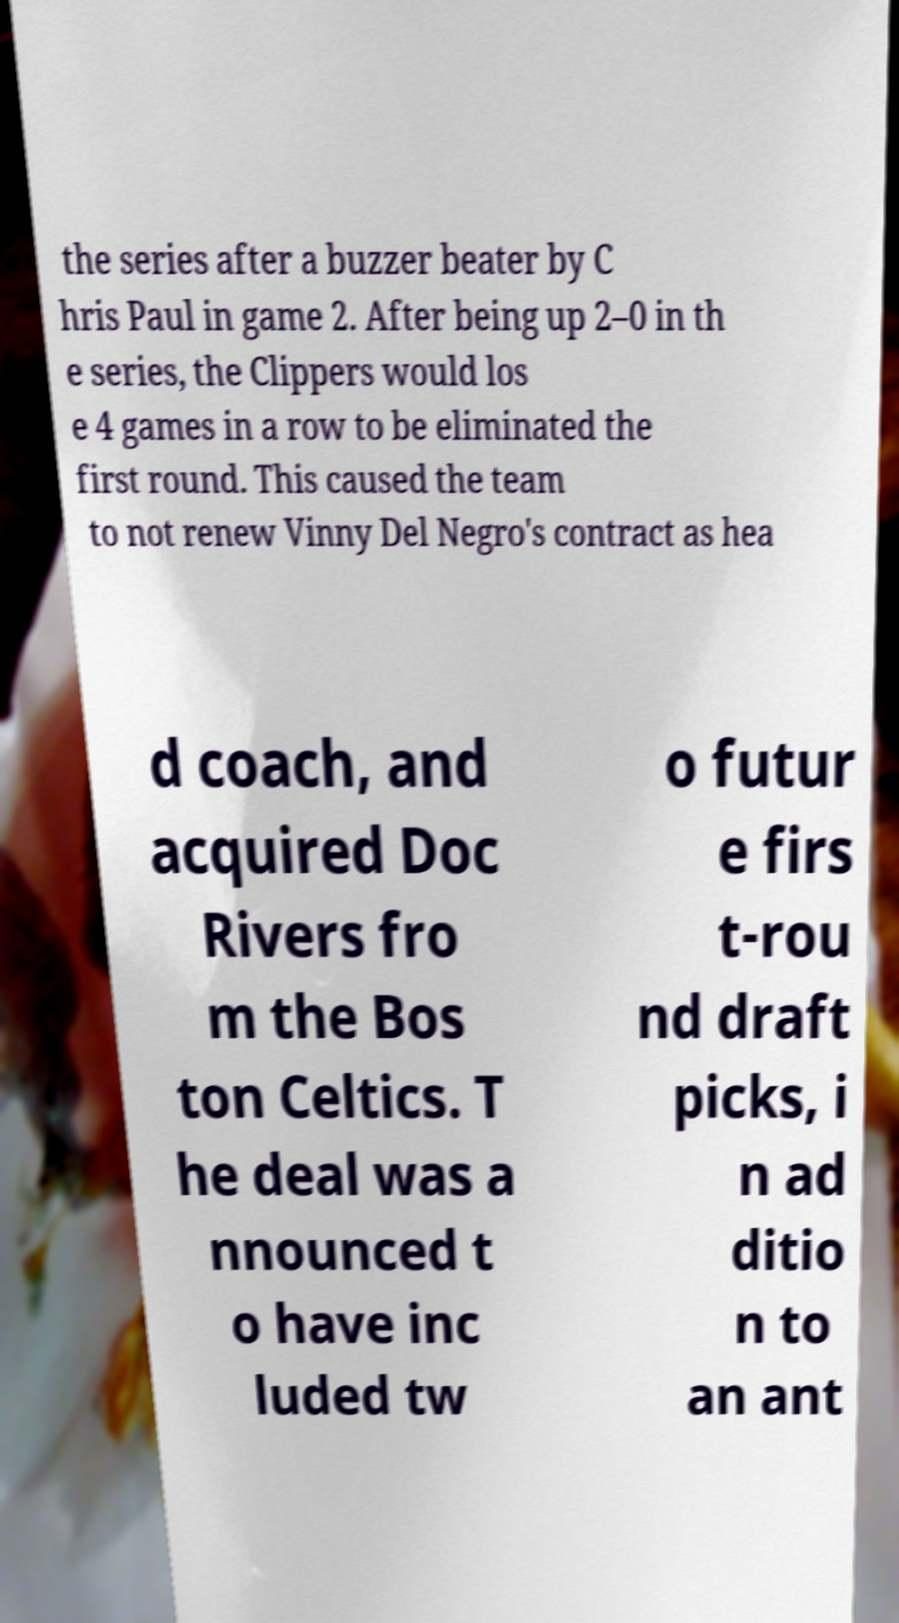I need the written content from this picture converted into text. Can you do that? the series after a buzzer beater by C hris Paul in game 2. After being up 2–0 in th e series, the Clippers would los e 4 games in a row to be eliminated the first round. This caused the team to not renew Vinny Del Negro's contract as hea d coach, and acquired Doc Rivers fro m the Bos ton Celtics. T he deal was a nnounced t o have inc luded tw o futur e firs t-rou nd draft picks, i n ad ditio n to an ant 